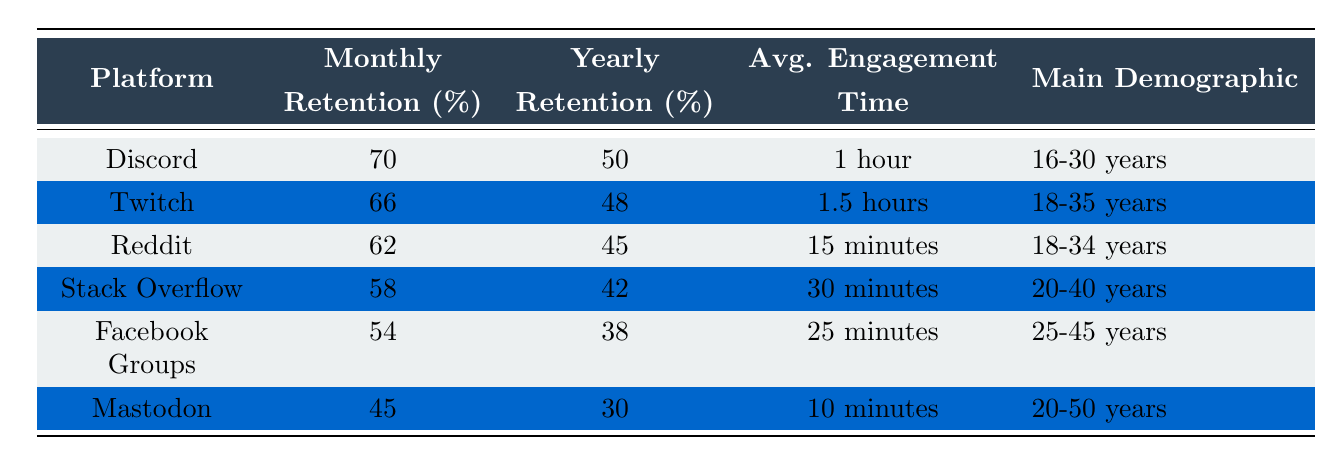What is the monthly retention rate for Discord? The table lists the monthly retention rates for each platform. For Discord, it specifically shows a monthly retention rate of 70%.
Answer: 70% Which platform has the highest yearly retention rate? By examining the yearly retention rates listed in the table, Discord has the highest yearly retention rate of 50%.
Answer: Discord What is the average engagement time of Stack Overflow users? The table specifies the average engagement time for each platform. For Stack Overflow, it lists an average engagement time of 30 minutes.
Answer: 30 minutes Is there a platform where the yearly retention rate is below 40%? By checking the yearly retention rates in the table, Mastodon has a yearly retention rate of 30%, which is indeed below 40%.
Answer: Yes What is the difference between the monthly retention rates of Reddit and Facebook Groups? We can find the monthly retention rates of Reddit (62%) and Facebook Groups (54%). The difference is calculated by subtracting: 62% - 54% = 8%.
Answer: 8% What is the average monthly retention rate of all platforms listed? First, we sum the monthly retention rates: 70 + 66 + 62 + 58 + 54 + 45 = 355. There are 6 platforms, so we divide by 6: 355/6 = approximately 59.17%.
Answer: 59.17% Which platform has the lowest average engagement time? Looking at the average engagement times in the table, Mastodon has the lowest at 10 minutes.
Answer: Mastodon Is the main demographic for Twitch older than that for Discord? The main demographic for Twitch is 18-35 years, and for Discord, it is 16-30 years. Since 18-35 includes an older age range than 16-30, it is not older.
Answer: No What is the yearly retention rate for Twitch and how does it compare to that of Stack Overflow? The yearly retention rate for Twitch is 48%, and for Stack Overflow, it is 42%. Comparing them shows that Twitch has a higher yearly retention rate than Stack Overflow.
Answer: Twitch is higher than Stack Overflow 